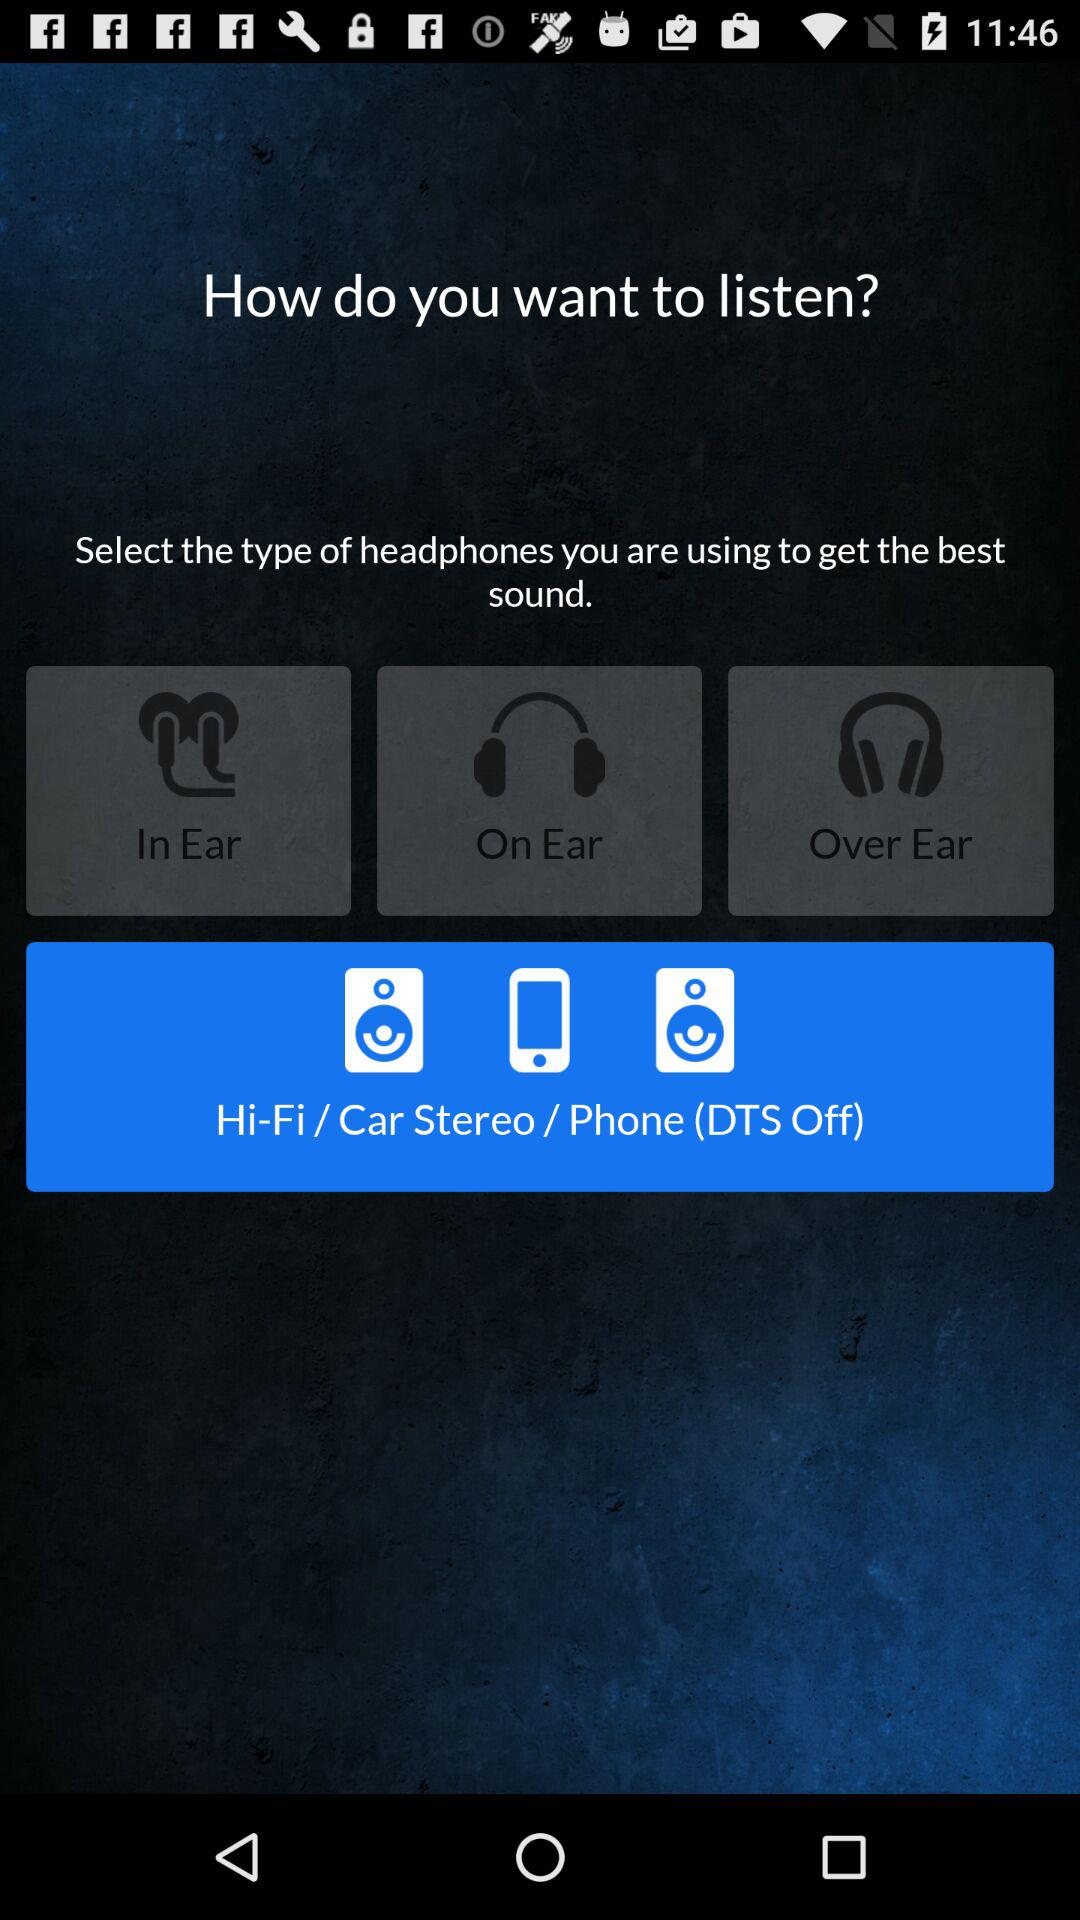How many headphones are there to choose from?
Answer the question using a single word or phrase. 3 